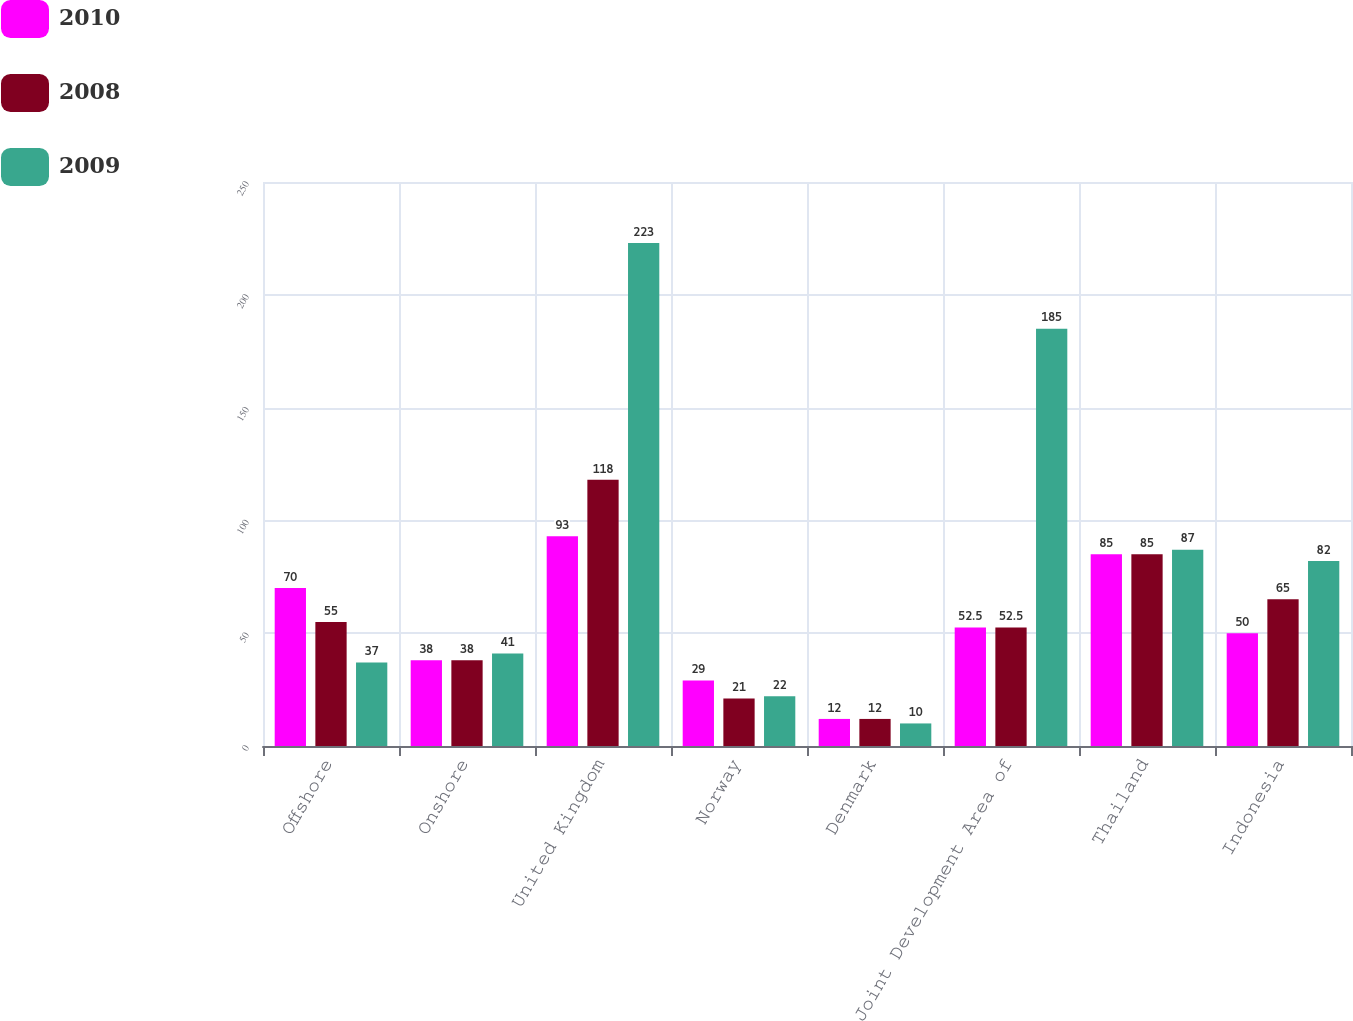Convert chart to OTSL. <chart><loc_0><loc_0><loc_500><loc_500><stacked_bar_chart><ecel><fcel>Offshore<fcel>Onshore<fcel>United Kingdom<fcel>Norway<fcel>Denmark<fcel>Joint Development Area of<fcel>Thailand<fcel>Indonesia<nl><fcel>2010<fcel>70<fcel>38<fcel>93<fcel>29<fcel>12<fcel>52.5<fcel>85<fcel>50<nl><fcel>2008<fcel>55<fcel>38<fcel>118<fcel>21<fcel>12<fcel>52.5<fcel>85<fcel>65<nl><fcel>2009<fcel>37<fcel>41<fcel>223<fcel>22<fcel>10<fcel>185<fcel>87<fcel>82<nl></chart> 